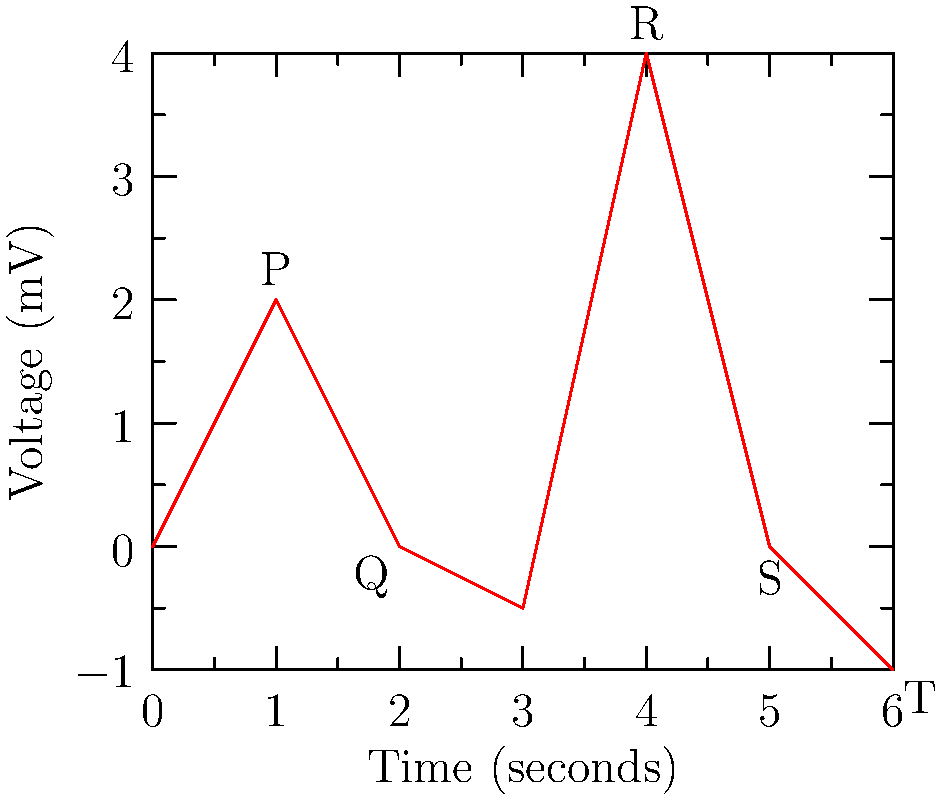In this ECG, which wave represents ventricular depolarization? To interpret this ECG and identify the wave representing ventricular depolarization, let's follow these steps:

1. Recall the components of a normal ECG:
   - P wave: Atrial depolarization
   - QRS complex: Ventricular depolarization
   - T wave: Ventricular repolarization

2. Identify the waves in the given ECG:
   - The first small positive deflection is the P wave
   - The small negative deflection following P is the Q wave
   - The large positive deflection is the R wave
   - The small negative deflection after R is the S wave
   - The final small positive deflection is the T wave

3. Remember that the QRS complex consists of the Q, R, and S waves combined

4. The QRS complex represents ventricular depolarization, which is the electrical activity that causes the ventricles to contract

5. In this ECG, the QRS complex is clearly visible as the combination of Q, R, and S waves, with the R wave being the most prominent

Therefore, the wave representing ventricular depolarization is the QRS complex, with the R wave being its most notable component.
Answer: QRS complex 